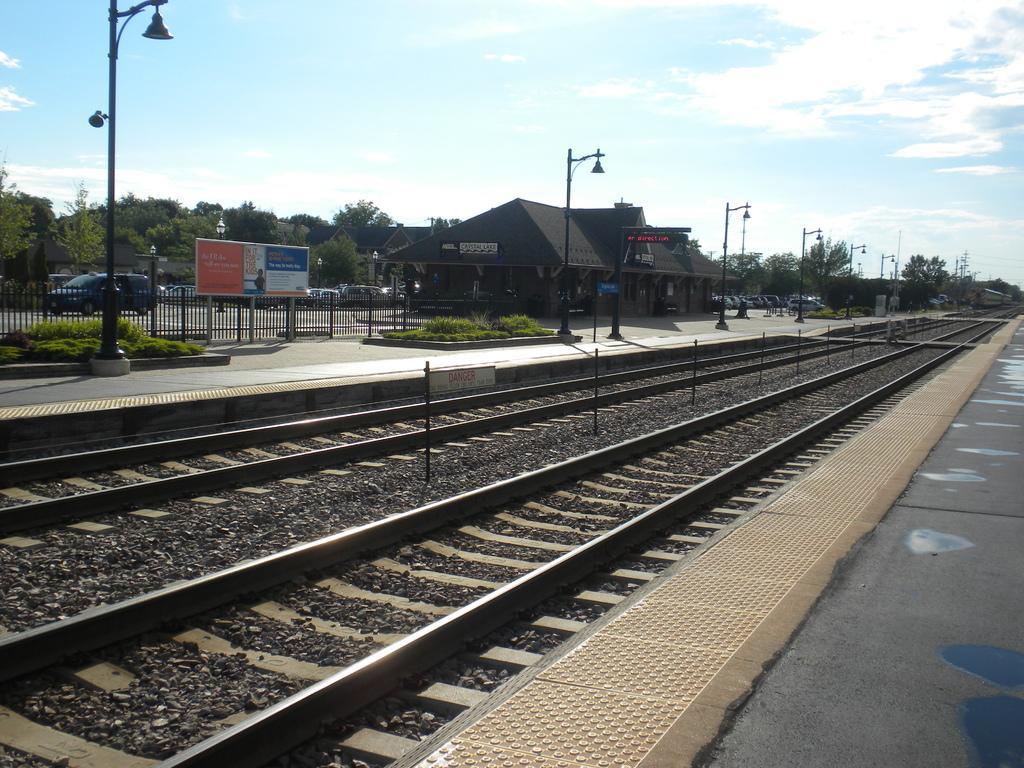How would you summarize this image in a sentence or two? In this image in front there is a platform. There is a railway track. There are poles. There are street lights. There is a metal fence. There is a hoarding. There are cars parked on the road. In the background of the image there are buildings, trees and sky. 